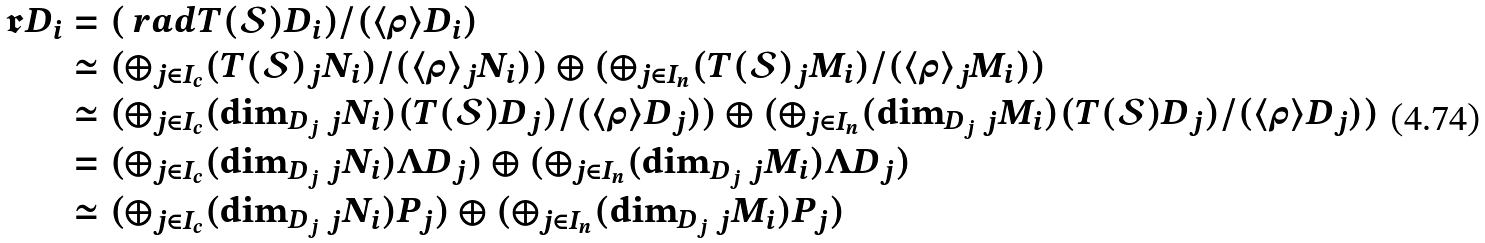<formula> <loc_0><loc_0><loc_500><loc_500>\mathfrak { r } D _ { i } & = ( \ r a d T ( \mathcal { S } ) D _ { i } ) / ( \langle \rho \rangle D _ { i } ) \\ & \simeq ( \oplus _ { j \in I _ { c } } ( T ( \mathcal { S } ) { _ { j } N _ { i } } ) / ( \langle \rho \rangle { _ { j } N _ { i } } ) ) \oplus ( \oplus _ { j \in I _ { n } } ( T ( \mathcal { S } ) { _ { j } M _ { i } } ) / ( \langle \rho \rangle { _ { j } M _ { i } } ) ) \\ & \simeq ( \oplus _ { j \in I _ { c } } ( \dim _ { D _ { j } } { _ { j } N _ { i } } ) ( T ( \mathcal { S } ) D _ { j } ) / ( \langle \rho \rangle D _ { j } ) ) \oplus ( \oplus _ { j \in I _ { n } } ( \dim _ { D _ { j } } { _ { j } M _ { i } } ) ( T ( \mathcal { S } ) D _ { j } ) / ( \langle \rho \rangle D _ { j } ) ) \\ & = ( \oplus _ { j \in I _ { c } } ( \dim _ { D _ { j } } { _ { j } N _ { i } } ) \Lambda D _ { j } ) \oplus ( \oplus _ { j \in I _ { n } } ( \dim _ { D _ { j } } { _ { j } M _ { i } } ) \Lambda D _ { j } ) \\ & \simeq ( \oplus _ { j \in I _ { c } } ( \dim _ { D _ { j } } { _ { j } N _ { i } } ) P _ { j } ) \oplus ( \oplus _ { j \in I _ { n } } ( \dim _ { D _ { j } } { _ { j } M _ { i } } ) P _ { j } )</formula> 